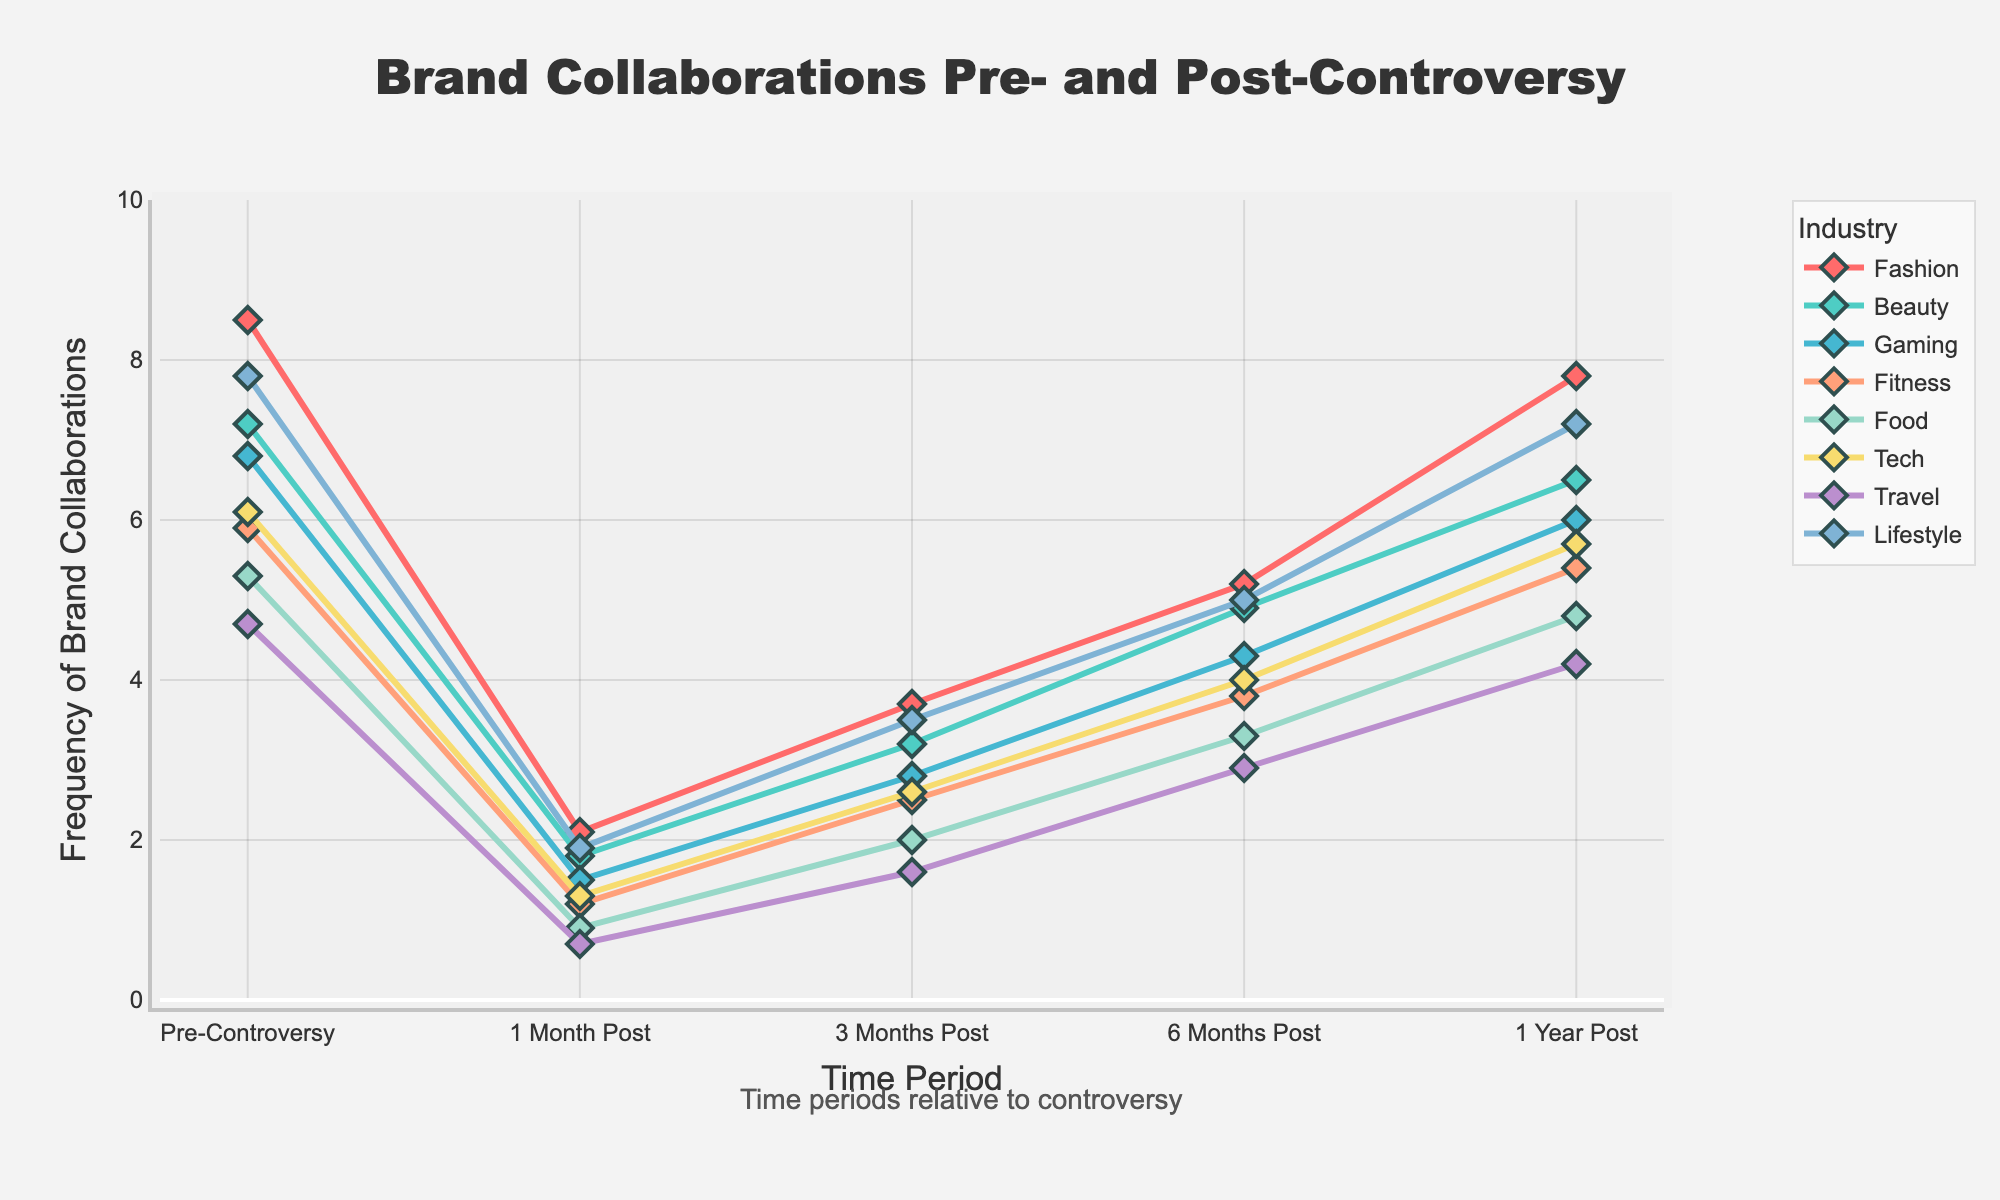Which industry showed the highest frequency of brand collaborations pre-controversy? The Fashion industry plot reaches the highest point among the 'Pre-Controversy' points. Each line represents a different industry, and the line for Fashion is the highest at the 'Pre-Controversy' time point.
Answer: Fashion How many industries exceeded 3 frequency of brand collaborations at 6 Months Post? Counting the lines crossing above the value 3 on the y-axis at the '6 Months Post' time point, it is observed: Fashion, Beauty, Gaming, Fitness, Tech, and Lifestyle.
Answer: 6 What is the average frequency of brand collaborations for the Beauty industry across all time points? Summing up the values of Beauty (7.2, 1.8, 3.2, 4.9, 6.5) equals 23.6. Dividing by the number of time points (5) gives 23.6 / 5 = 4.72.
Answer: 4.72 Which time point shows the largest drop in brand collaborations for the Tech industry compared to the previous time point? Calculating the difference between consecutive time points for Tech (6.1 - 1.3 = 4.8, 1.3 - 2.6 = -1.3, 2.6 - 4.0 = -1.4, 4.0 - 5.7 = -1.7), the largest drop is from 'Pre-Controversy' to '1 Month Post' where the decrease is 4.8.
Answer: 1 Month Post Which industries have made a complete recovery to their pre-controversy frequency levels by 1 Year Post? Comparing '1 Year Post' values to 'Pre-Controversy' values for each industry: Only Lifestyle (7.8 to 7.2) and Fashion (8.5 to 7.8) are near pre-controversy levels, though not identical, showing substantial recovery but not complete.
Answer: None By how much did the frequency of brand collaborations in the Travel industry increase from 1 Month Post to 1 Year Post? Subtracting the '1 Month Post' value from the '1 Year Post' value for Travel (4.2 - 0.7 = 3.5) shows an increase of 3.5.
Answer: 3.5 Which time period shows the most noticeable recovery trend for the Gaming industry? Observing Gaming's values from '1 Month Post' (1.5) through each subsequent period until '1 Year Post' (6.0), most significant upward trend appears between '1 Month Post' to '1 Year Post'.
Answer: 1 Year Post Is there a time point where all industries are below their pre-controversy levels? At '1 Month Post', all lines for every industry are lower than their corresponding 'Pre-Controversy' points indicating every industry experienced a drop.
Answer: 1 Month Post 